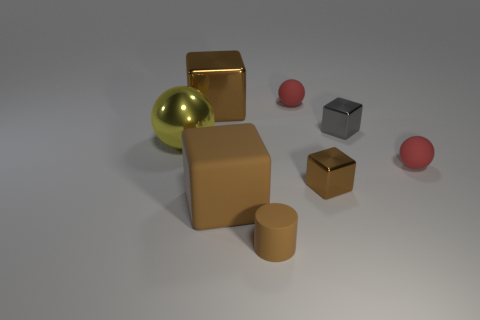How many brown blocks must be subtracted to get 1 brown blocks? 2 Subtract all cyan balls. How many brown blocks are left? 3 Subtract all yellow cubes. Subtract all blue spheres. How many cubes are left? 4 Add 1 tiny blue metal cubes. How many objects exist? 9 Subtract all cylinders. How many objects are left? 7 Add 6 rubber cylinders. How many rubber cylinders are left? 7 Add 7 big matte cubes. How many big matte cubes exist? 8 Subtract 0 red cubes. How many objects are left? 8 Subtract all large yellow metallic balls. Subtract all big shiny blocks. How many objects are left? 6 